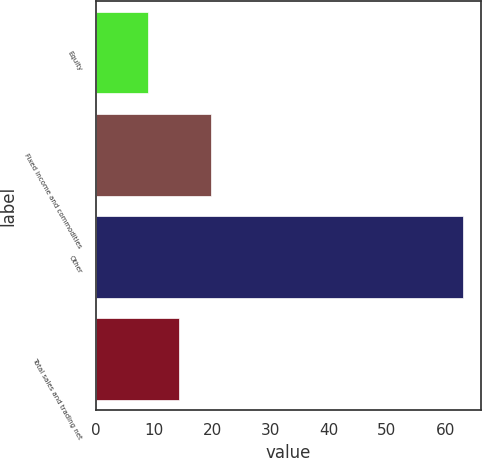Convert chart. <chart><loc_0><loc_0><loc_500><loc_500><bar_chart><fcel>Equity<fcel>Fixed income and commodities<fcel>Other<fcel>Total sales and trading net<nl><fcel>9<fcel>19.8<fcel>63<fcel>14.4<nl></chart> 